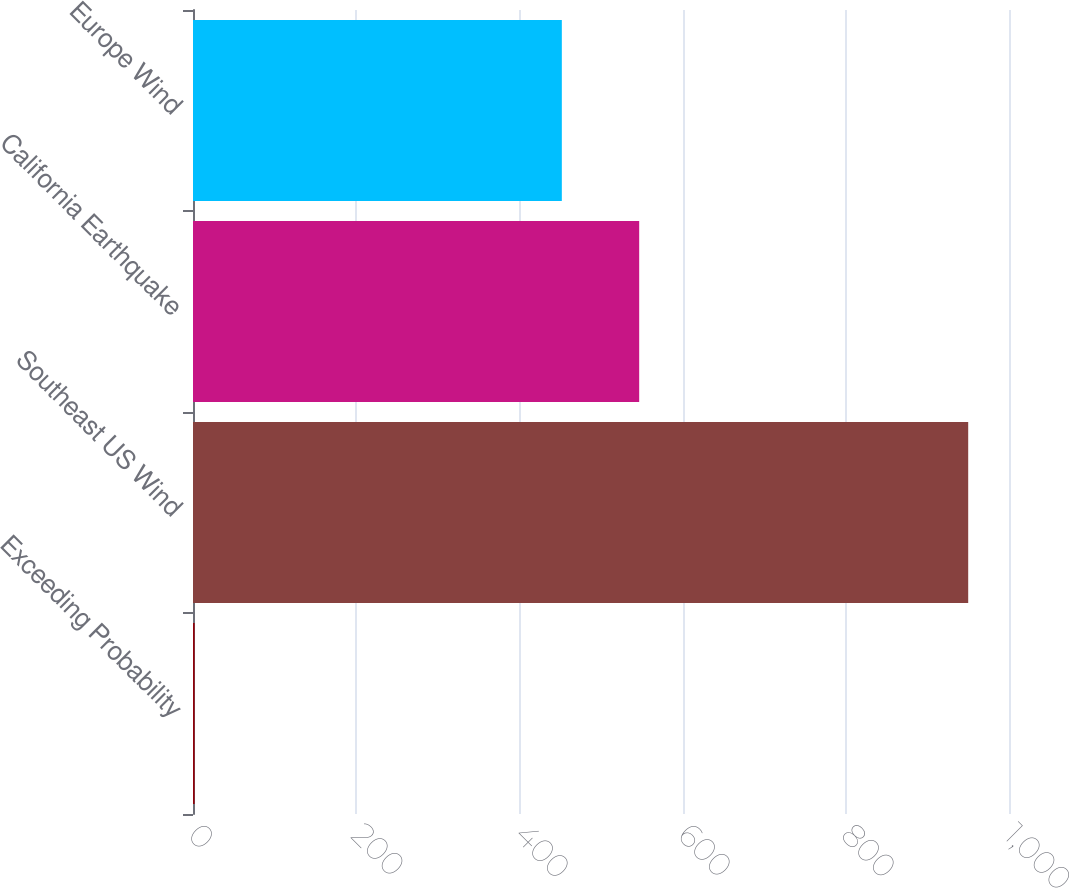<chart> <loc_0><loc_0><loc_500><loc_500><bar_chart><fcel>Exceeding Probability<fcel>Southeast US Wind<fcel>California Earthquake<fcel>Europe Wind<nl><fcel>2<fcel>950<fcel>546.8<fcel>452<nl></chart> 